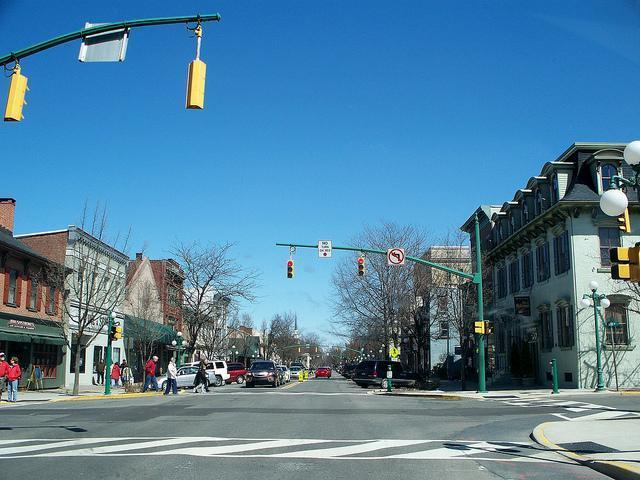How many apple iphones are there?
Give a very brief answer. 0. 